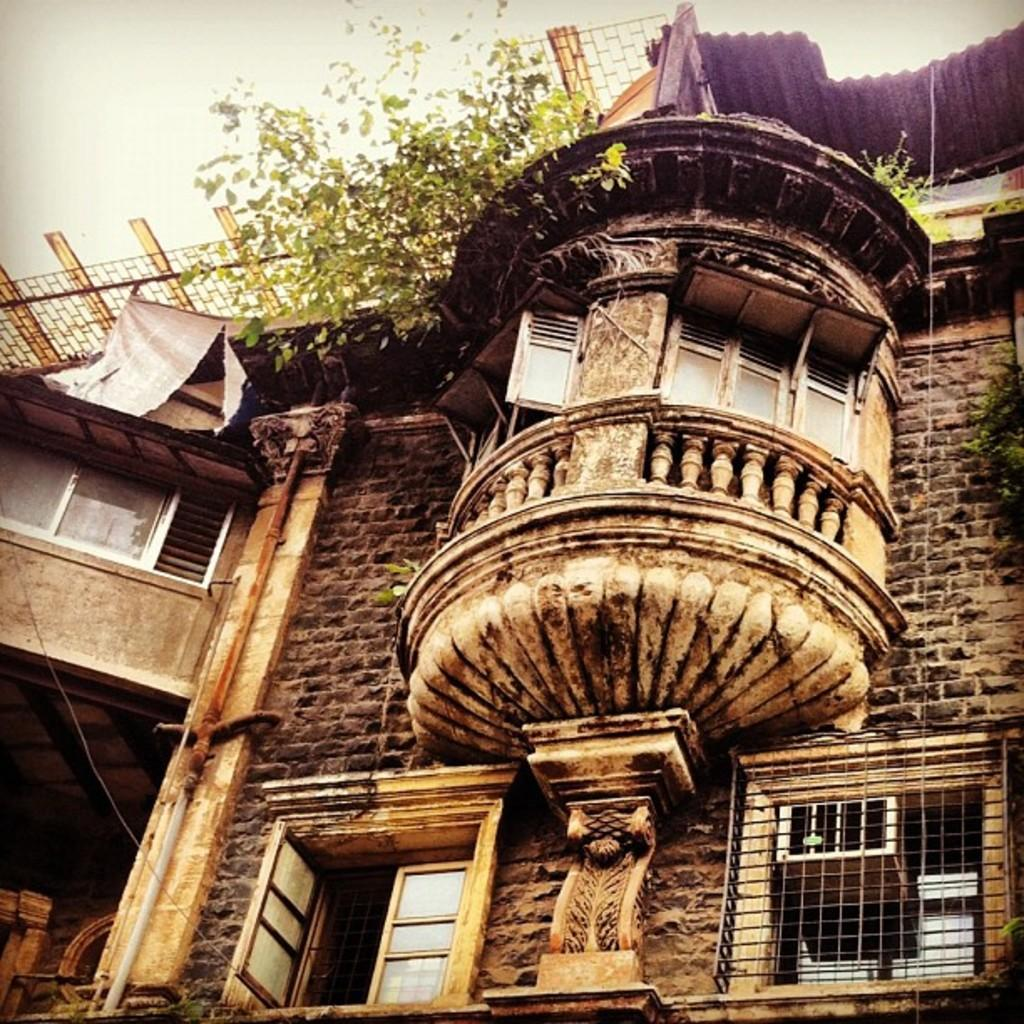What type of structure is present in the image? There is a building in the image. What feature can be seen on the building? The building has windows. What else is visible in the image besides the building? There is a wire visible in the image. What can be seen in the background of the image? There are plants in the background of the image. What type of work is the lawyer doing in the image? There is no lawyer present in the image, so it is not possible to determine what work they might be doing. 